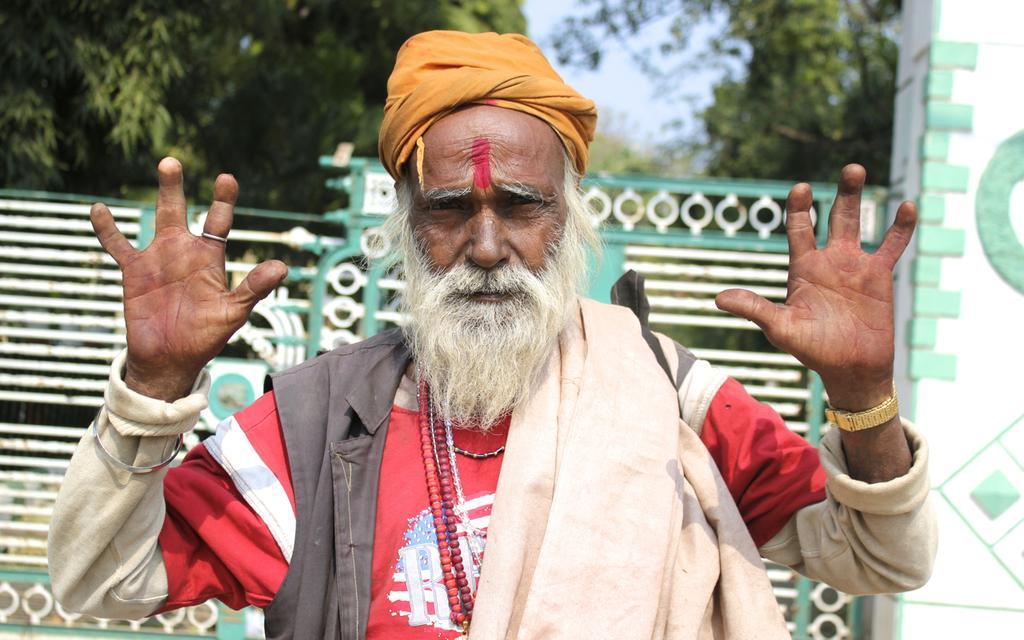Please provide a concise description of this image. In the picture we can see a old man with a white beard and showing his two hands with eight fingers to it and behind him we can see a gate and behind it we can see some trees and sky. 